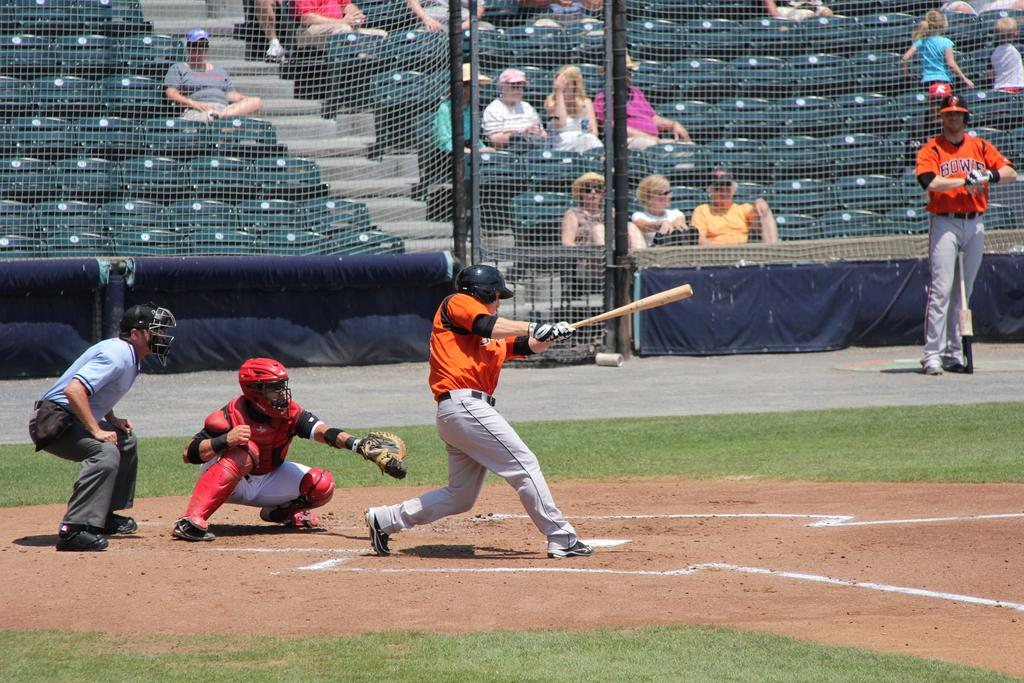<image>
Present a compact description of the photo's key features. a player on the on deck circle with the letters BOW on his shirt 